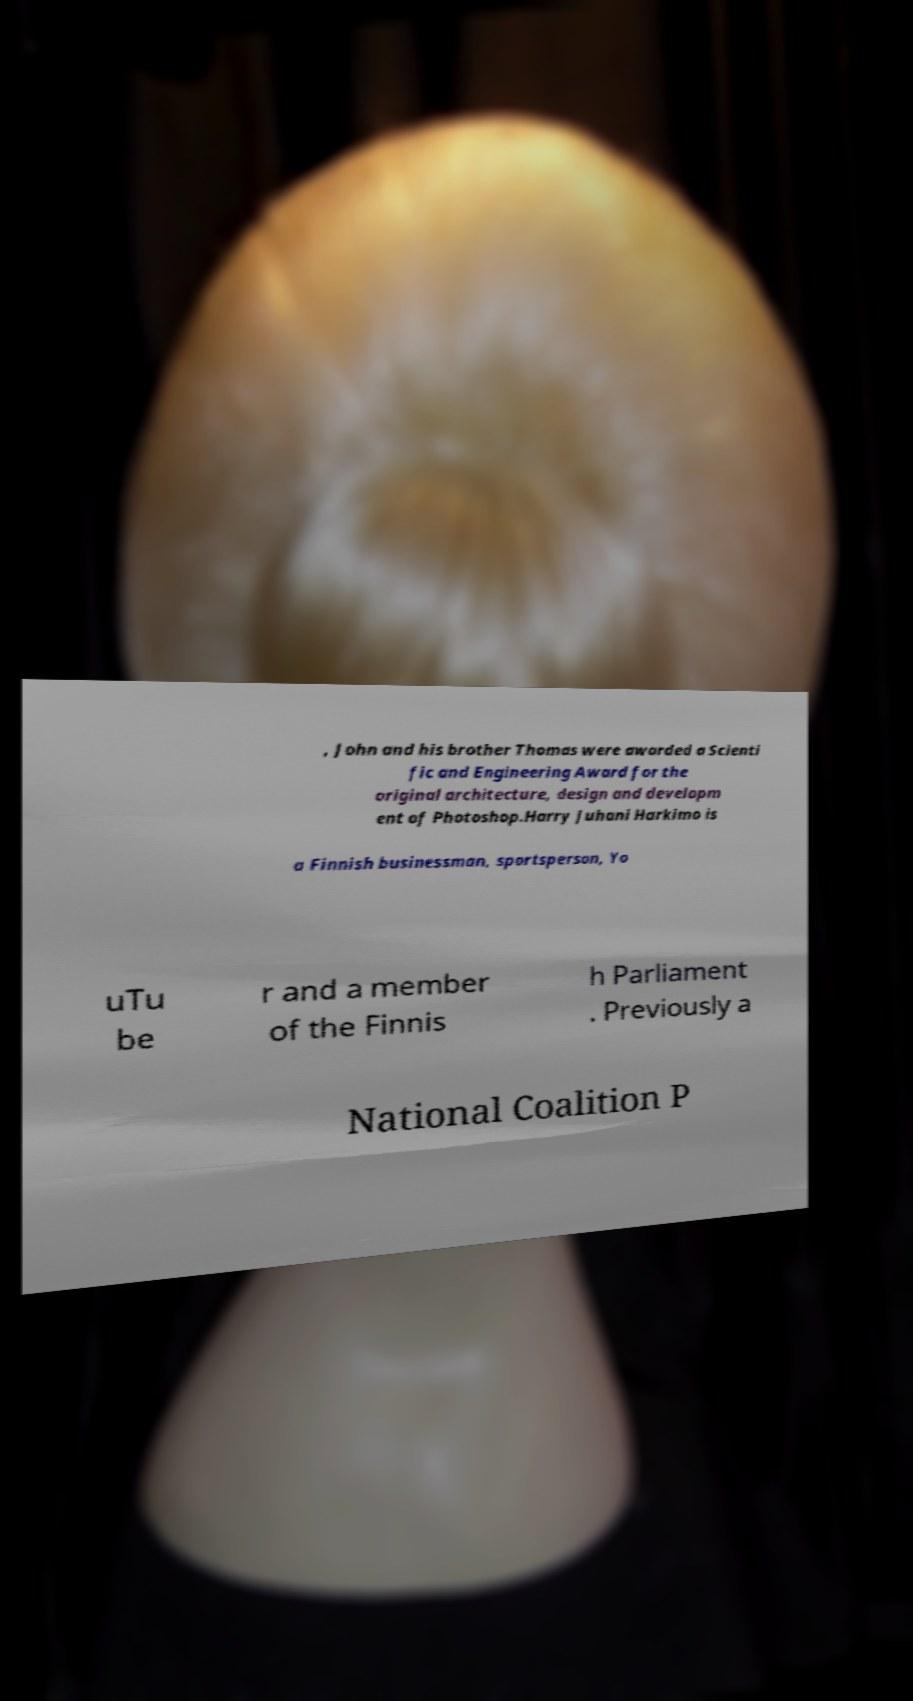Could you extract and type out the text from this image? , John and his brother Thomas were awarded a Scienti fic and Engineering Award for the original architecture, design and developm ent of Photoshop.Harry Juhani Harkimo is a Finnish businessman, sportsperson, Yo uTu be r and a member of the Finnis h Parliament . Previously a National Coalition P 